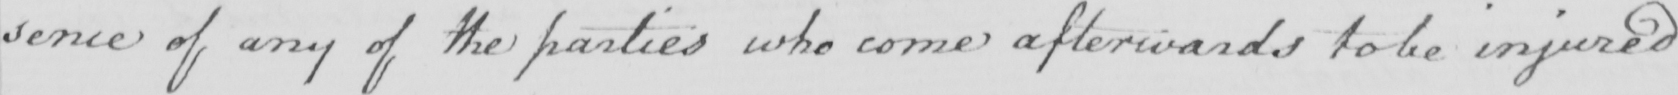What text is written in this handwritten line? sence of any of the parties who come afterwards to be injured 